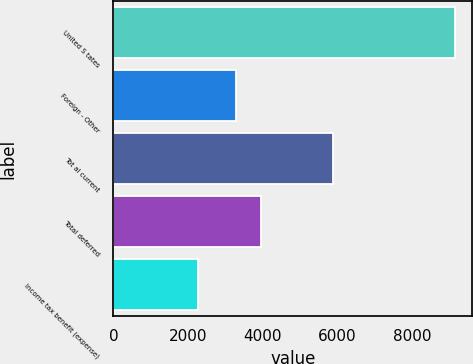Convert chart. <chart><loc_0><loc_0><loc_500><loc_500><bar_chart><fcel>United S tates<fcel>Foreign - Other<fcel>Tot al current<fcel>Total deferred<fcel>Income tax benefit (expense)<nl><fcel>9162<fcel>3278<fcel>5884<fcel>3967.5<fcel>2267<nl></chart> 